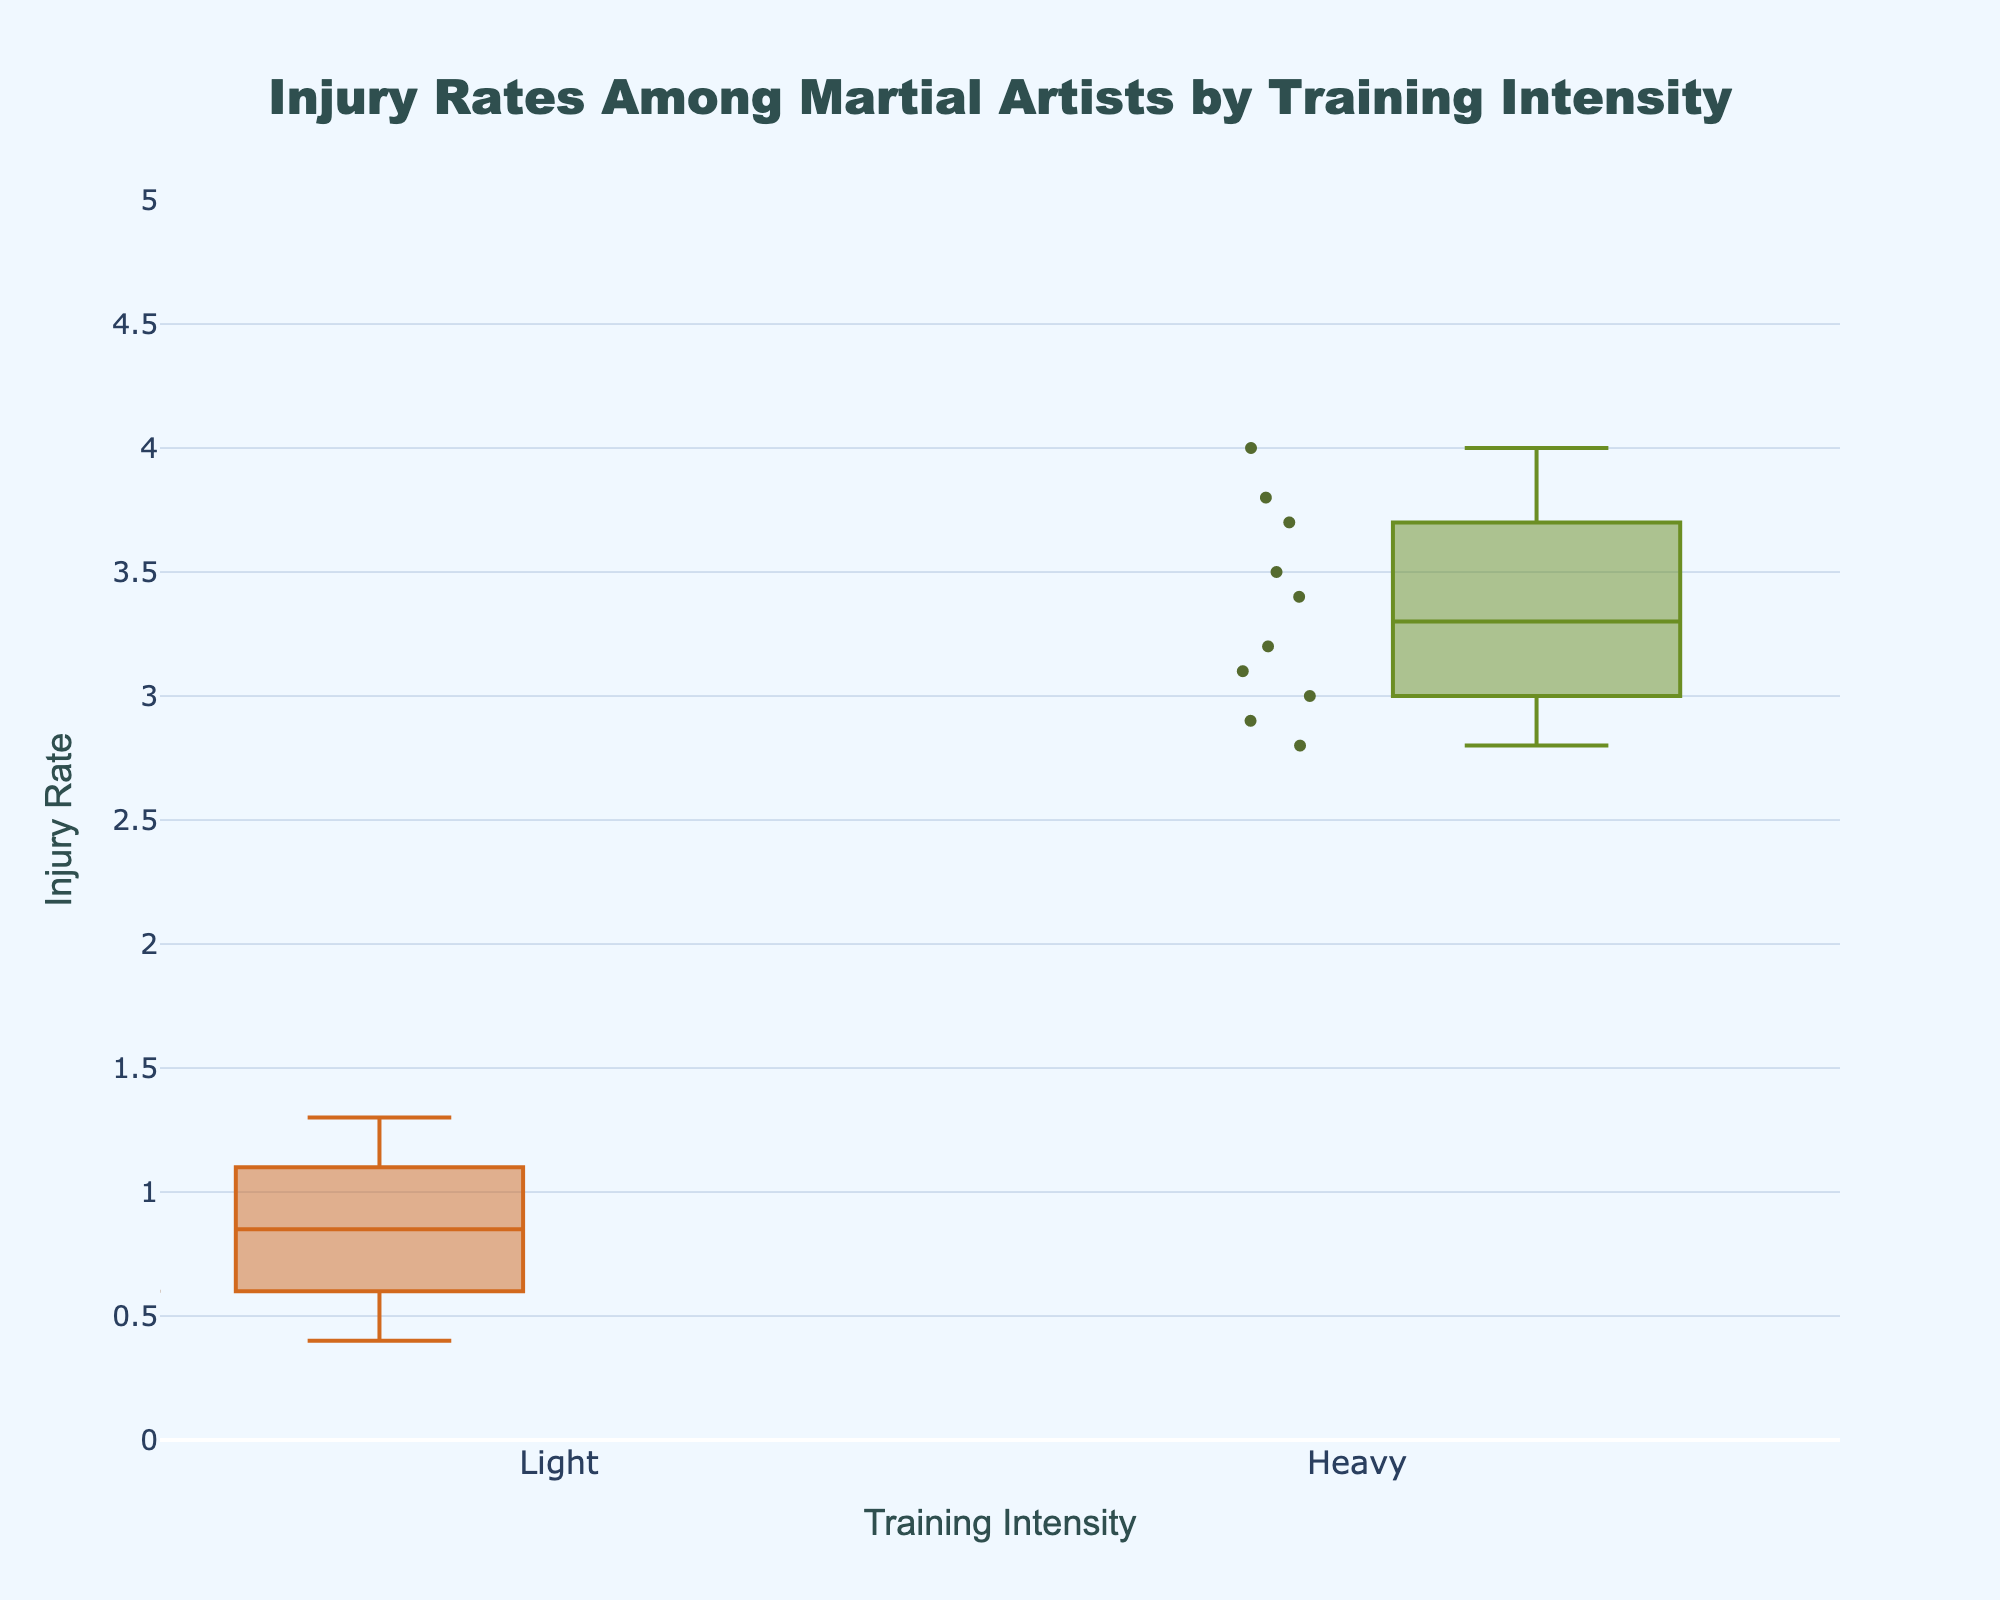What is the title of the plot? The title of the plot is located at the top center of the figure in a larger font size. It reads: "Injury Rates Among Martial Artists by Training Intensity"
Answer: Injury Rates Among Martial Artists by Training Intensity What are the labels used on the x-axis and y-axis? The x-axis label is "Training Intensity" and the y-axis label is "Injury Rate". These are shown on the respective axis of the figure.
Answer: Training Intensity; Injury Rate What are the two groups compared in the plot? The two groups being compared are indicated by the box plots' names on the x-axis and they are labeled as 'Light' and 'Heavy'.
Answer: Light; Heavy Which group has a higher median injury rate? To find the group with the higher median injury rate, observe the middle line of each box plot. The middle line of the 'Heavy' group is higher than that of the 'Light' group.
Answer: Heavy What is the highest injury rate recorded under heavy training intensity? The highest point in the 'Heavy' training intensity box plot represents the highest injury rate. This point is located at the top of the 'Heavy' box plot, which is 4.0.
Answer: 4.0 What is the range of y-values used in the plot? The y-axis starts at 0 and goes up to 5. This can be identified by looking at the tick marks on the y-axis.
Answer: 0 to 5 How many data points are plotted for the 'Light' intensity group? The number of data points can be counted by looking at the individual dots representing the data in the 'Light' box plot. There are 10 points for the 'Light' group.
Answer: 10 What is the median injury rate for the light training intensity? The median is indicated by the line within the box. For the 'Light' group, this line is at the value 0.85.
Answer: 0.85 What is the interquartile range for the heavy training intensity group? The interquartile range (IQR) is the difference between the third quartile (upper boundary of the box) and the first quartile (lower boundary of the box). For the 'Heavy' group, the IQR is 3.6 (third quartile) - 3.0 (first quartile) = 0.6.
Answer: 0.6 Which group has more variability in the injury rates? Variability can be assessed by looking at the span of the whiskers and the spread of the individual data points. The 'Heavy' group has a wider spread of values and longer whiskers, indicating more variability.
Answer: Heavy 